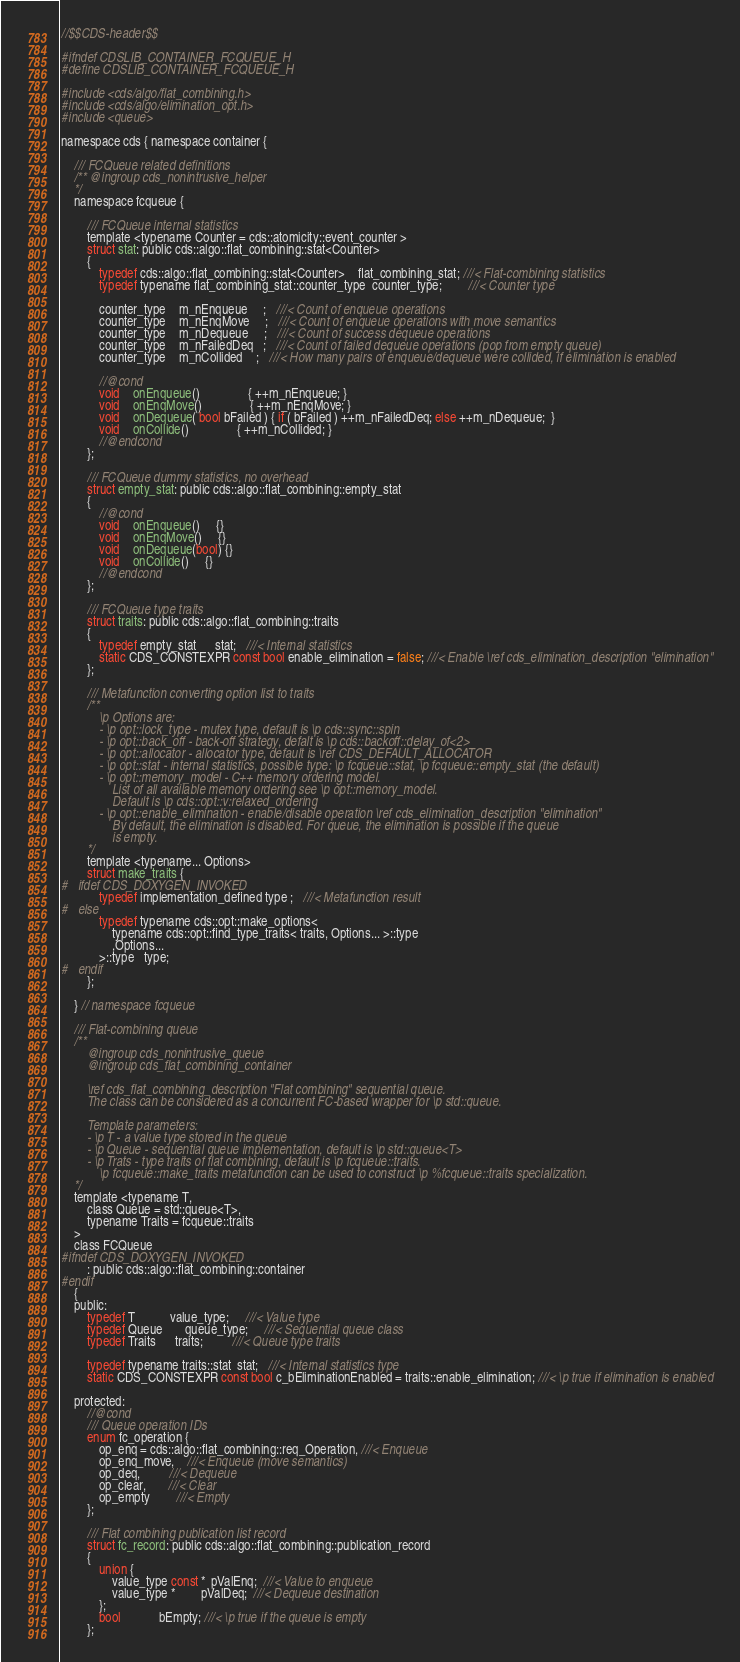<code> <loc_0><loc_0><loc_500><loc_500><_C_>//$$CDS-header$$

#ifndef CDSLIB_CONTAINER_FCQUEUE_H
#define CDSLIB_CONTAINER_FCQUEUE_H

#include <cds/algo/flat_combining.h>
#include <cds/algo/elimination_opt.h>
#include <queue>

namespace cds { namespace container {

    /// FCQueue related definitions
    /** @ingroup cds_nonintrusive_helper
    */
    namespace fcqueue {

        /// FCQueue internal statistics
        template <typename Counter = cds::atomicity::event_counter >
        struct stat: public cds::algo::flat_combining::stat<Counter>
        {
            typedef cds::algo::flat_combining::stat<Counter>    flat_combining_stat; ///< Flat-combining statistics
            typedef typename flat_combining_stat::counter_type  counter_type;        ///< Counter type

            counter_type    m_nEnqueue     ;   ///< Count of enqueue operations
            counter_type    m_nEnqMove     ;   ///< Count of enqueue operations with move semantics
            counter_type    m_nDequeue     ;   ///< Count of success dequeue operations
            counter_type    m_nFailedDeq   ;   ///< Count of failed dequeue operations (pop from empty queue)
            counter_type    m_nCollided    ;   ///< How many pairs of enqueue/dequeue were collided, if elimination is enabled

            //@cond
            void    onEnqueue()               { ++m_nEnqueue; }
            void    onEnqMove()               { ++m_nEnqMove; }
            void    onDequeue( bool bFailed ) { if ( bFailed ) ++m_nFailedDeq; else ++m_nDequeue;  }
            void    onCollide()               { ++m_nCollided; }
            //@endcond
        };

        /// FCQueue dummy statistics, no overhead
        struct empty_stat: public cds::algo::flat_combining::empty_stat
        {
            //@cond
            void    onEnqueue()     {}
            void    onEnqMove()     {}
            void    onDequeue(bool) {}
            void    onCollide()     {}
            //@endcond
        };

        /// FCQueue type traits
        struct traits: public cds::algo::flat_combining::traits
        {
            typedef empty_stat      stat;   ///< Internal statistics
            static CDS_CONSTEXPR const bool enable_elimination = false; ///< Enable \ref cds_elimination_description "elimination"
        };

        /// Metafunction converting option list to traits
        /**
            \p Options are:
            - \p opt::lock_type - mutex type, default is \p cds::sync::spin
            - \p opt::back_off - back-off strategy, defalt is \p cds::backoff::delay_of<2>
            - \p opt::allocator - allocator type, default is \ref CDS_DEFAULT_ALLOCATOR
            - \p opt::stat - internal statistics, possible type: \p fcqueue::stat, \p fcqueue::empty_stat (the default)
            - \p opt::memory_model - C++ memory ordering model.
                List of all available memory ordering see \p opt::memory_model.
                Default is \p cds::opt::v:relaxed_ordering
            - \p opt::enable_elimination - enable/disable operation \ref cds_elimination_description "elimination"
                By default, the elimination is disabled. For queue, the elimination is possible if the queue
                is empty.
        */
        template <typename... Options>
        struct make_traits {
#   ifdef CDS_DOXYGEN_INVOKED
            typedef implementation_defined type ;   ///< Metafunction result
#   else
            typedef typename cds::opt::make_options<
                typename cds::opt::find_type_traits< traits, Options... >::type
                ,Options...
            >::type   type;
#   endif
        };

    } // namespace fcqueue

    /// Flat-combining queue
    /**
        @ingroup cds_nonintrusive_queue
        @ingroup cds_flat_combining_container

        \ref cds_flat_combining_description "Flat combining" sequential queue.
        The class can be considered as a concurrent FC-based wrapper for \p std::queue.

        Template parameters:
        - \p T - a value type stored in the queue
        - \p Queue - sequential queue implementation, default is \p std::queue<T>
        - \p Trats - type traits of flat combining, default is \p fcqueue::traits.
            \p fcqueue::make_traits metafunction can be used to construct \p %fcqueue::traits specialization.
    */
    template <typename T,
        class Queue = std::queue<T>,
        typename Traits = fcqueue::traits
    >
    class FCQueue
#ifndef CDS_DOXYGEN_INVOKED
        : public cds::algo::flat_combining::container
#endif
    {
    public:
        typedef T           value_type;     ///< Value type
        typedef Queue       queue_type;     ///< Sequential queue class
        typedef Traits      traits;         ///< Queue type traits

        typedef typename traits::stat  stat;   ///< Internal statistics type
        static CDS_CONSTEXPR const bool c_bEliminationEnabled = traits::enable_elimination; ///< \p true if elimination is enabled

    protected:
        //@cond
        /// Queue operation IDs
        enum fc_operation {
            op_enq = cds::algo::flat_combining::req_Operation, ///< Enqueue
            op_enq_move,    ///< Enqueue (move semantics)
            op_deq,         ///< Dequeue
            op_clear,       ///< Clear
            op_empty        ///< Empty
        };

        /// Flat combining publication list record
        struct fc_record: public cds::algo::flat_combining::publication_record
        {
            union {
                value_type const *  pValEnq;  ///< Value to enqueue
                value_type *        pValDeq;  ///< Dequeue destination
            };
            bool            bEmpty; ///< \p true if the queue is empty
        };</code> 